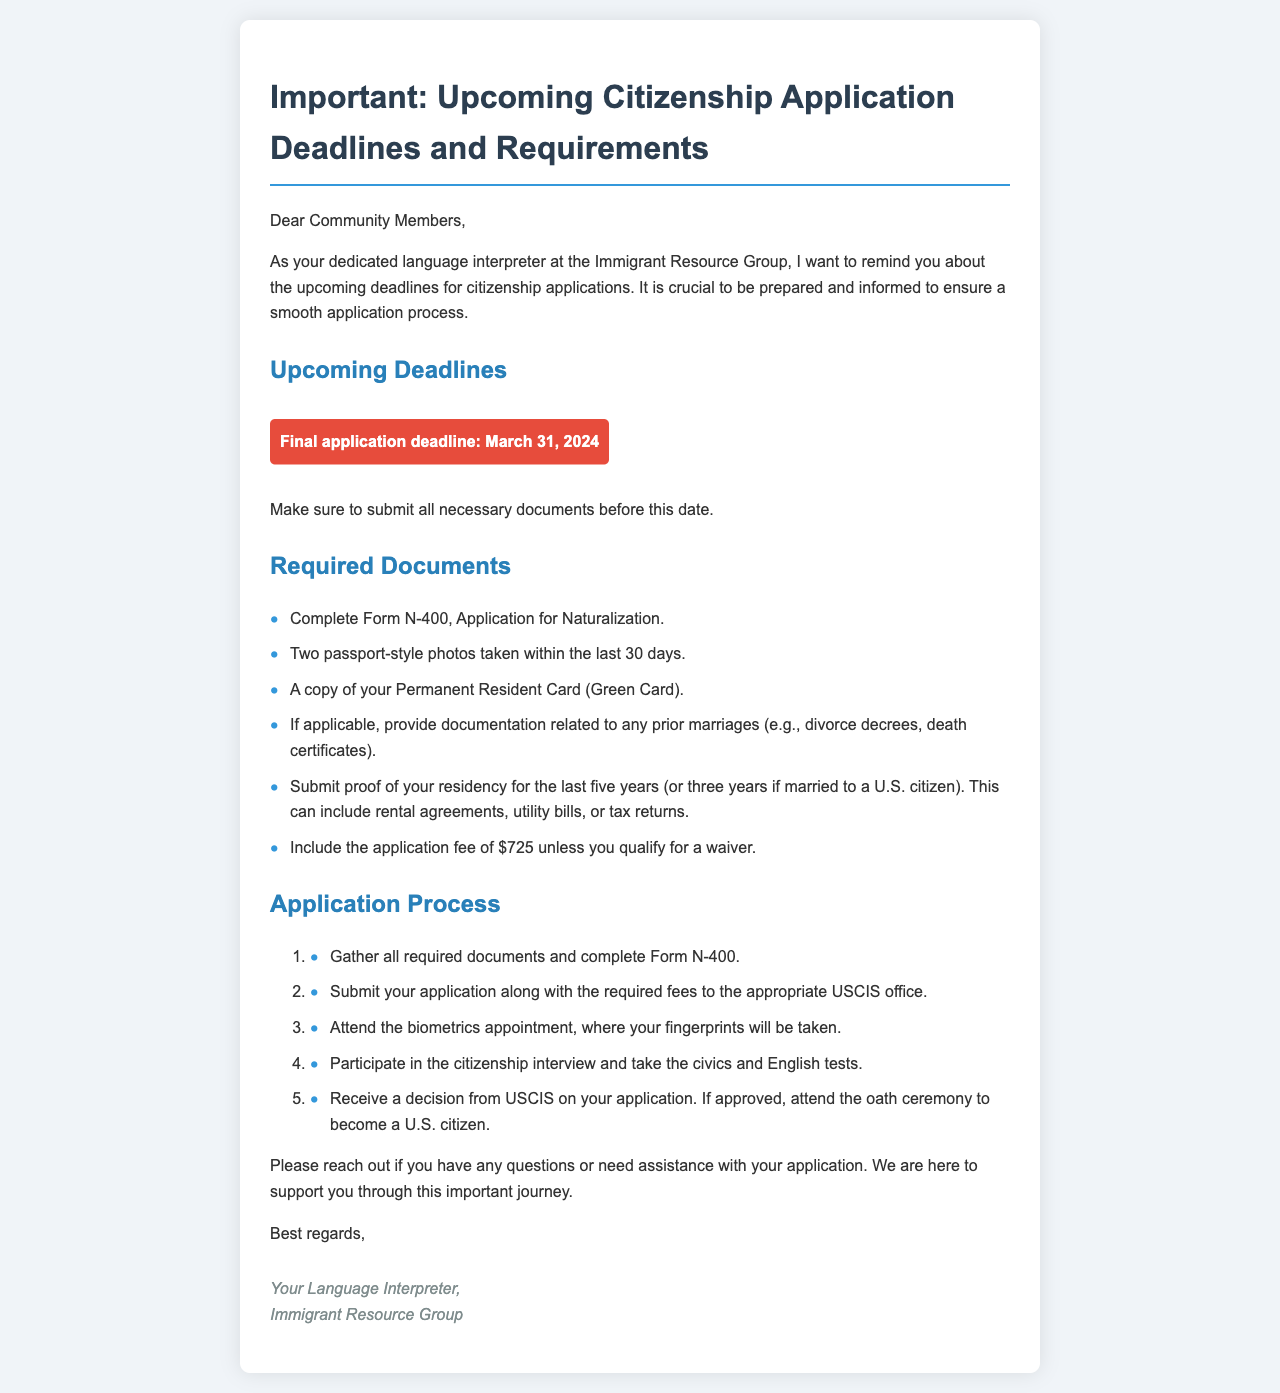What is the final application deadline? The final application deadline is a specific date mentioned in the document, which is March 31, 2024.
Answer: March 31, 2024 How many passport-style photos are required? The document states that two passport-style photos are necessary for the application process.
Answer: Two What form needs to be completed for naturalization? The required form for application is explicitly named in the document as Form N-400.
Answer: Form N-400 What is the application fee unless you qualify for a waiver? The document specifies the application fee associated with the citizenship application, which is $725.
Answer: $725 How many steps are in the application process? The steps in the application process are listed in an ordered list in the document, totaling five steps.
Answer: Five What type of documentation is needed for prior marriages? The document specifies that divorce decrees or death certificates are necessary if applicable.
Answer: Divorce decrees, death certificates What happens after a decision from USCIS if approved? The document explains that if approved, the individual must attend the oath ceremony to become a U.S. citizen.
Answer: Attend the oath ceremony Who can you reach out to if you have questions? The document encourages reaching out to the language interpreter as a point of contact for assistance.
Answer: Your Language Interpreter 